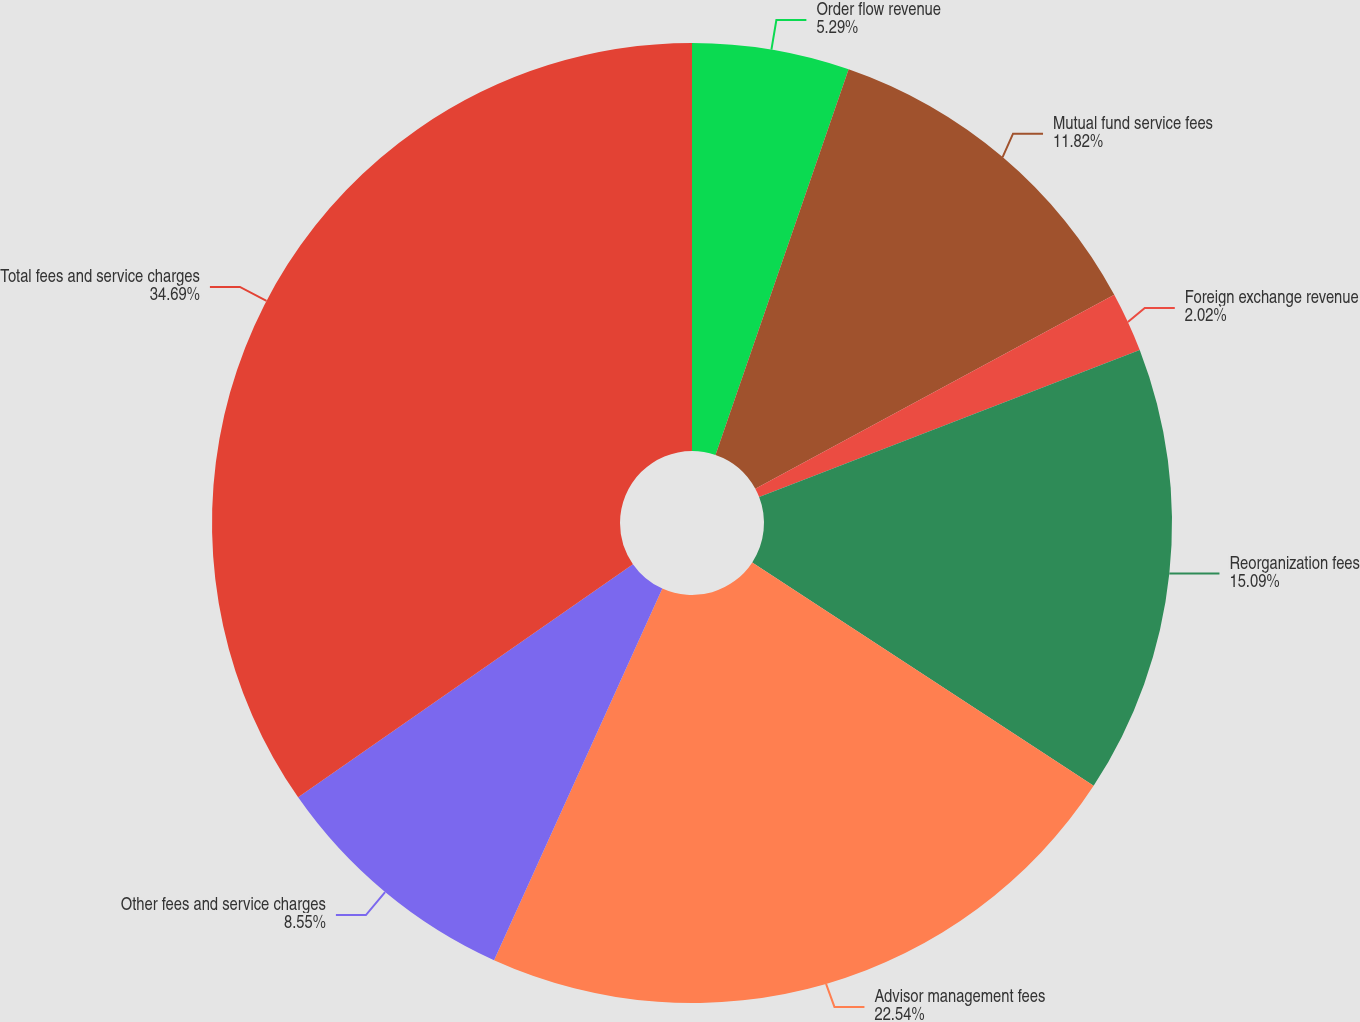Convert chart. <chart><loc_0><loc_0><loc_500><loc_500><pie_chart><fcel>Order flow revenue<fcel>Mutual fund service fees<fcel>Foreign exchange revenue<fcel>Reorganization fees<fcel>Advisor management fees<fcel>Other fees and service charges<fcel>Total fees and service charges<nl><fcel>5.29%<fcel>11.82%<fcel>2.02%<fcel>15.09%<fcel>22.54%<fcel>8.55%<fcel>34.68%<nl></chart> 